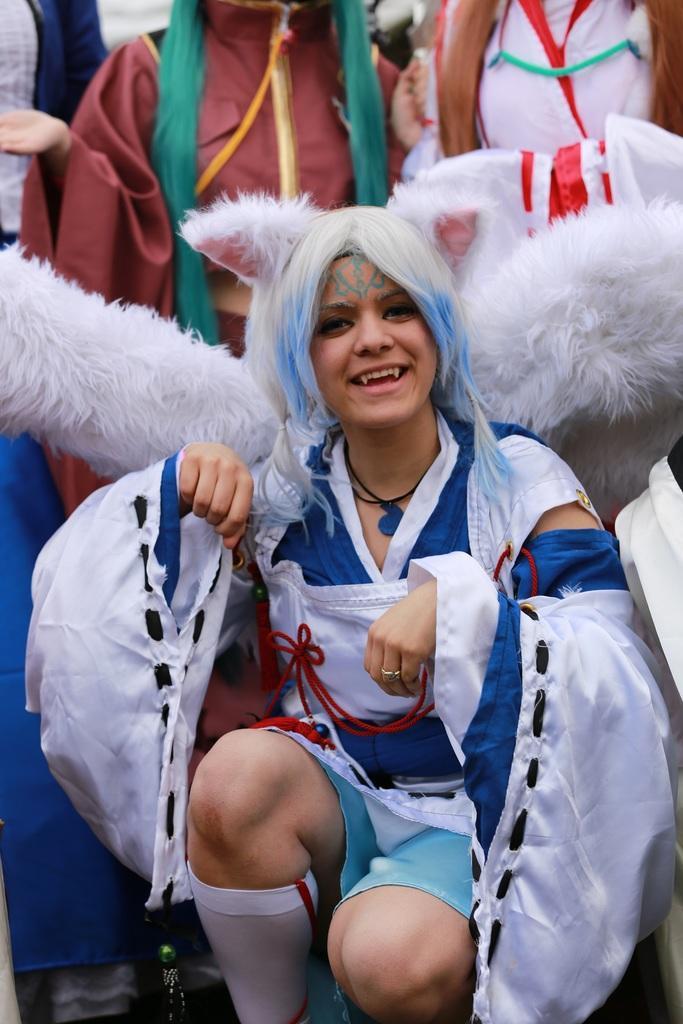Can you describe this image briefly? Here we can see a girl posing in a Halloween costume for a photo. She is wearing a blue costume with white skirt and wearing white socks. Her is hair is colored white and blue. Behind her there are other people in different costumes. 